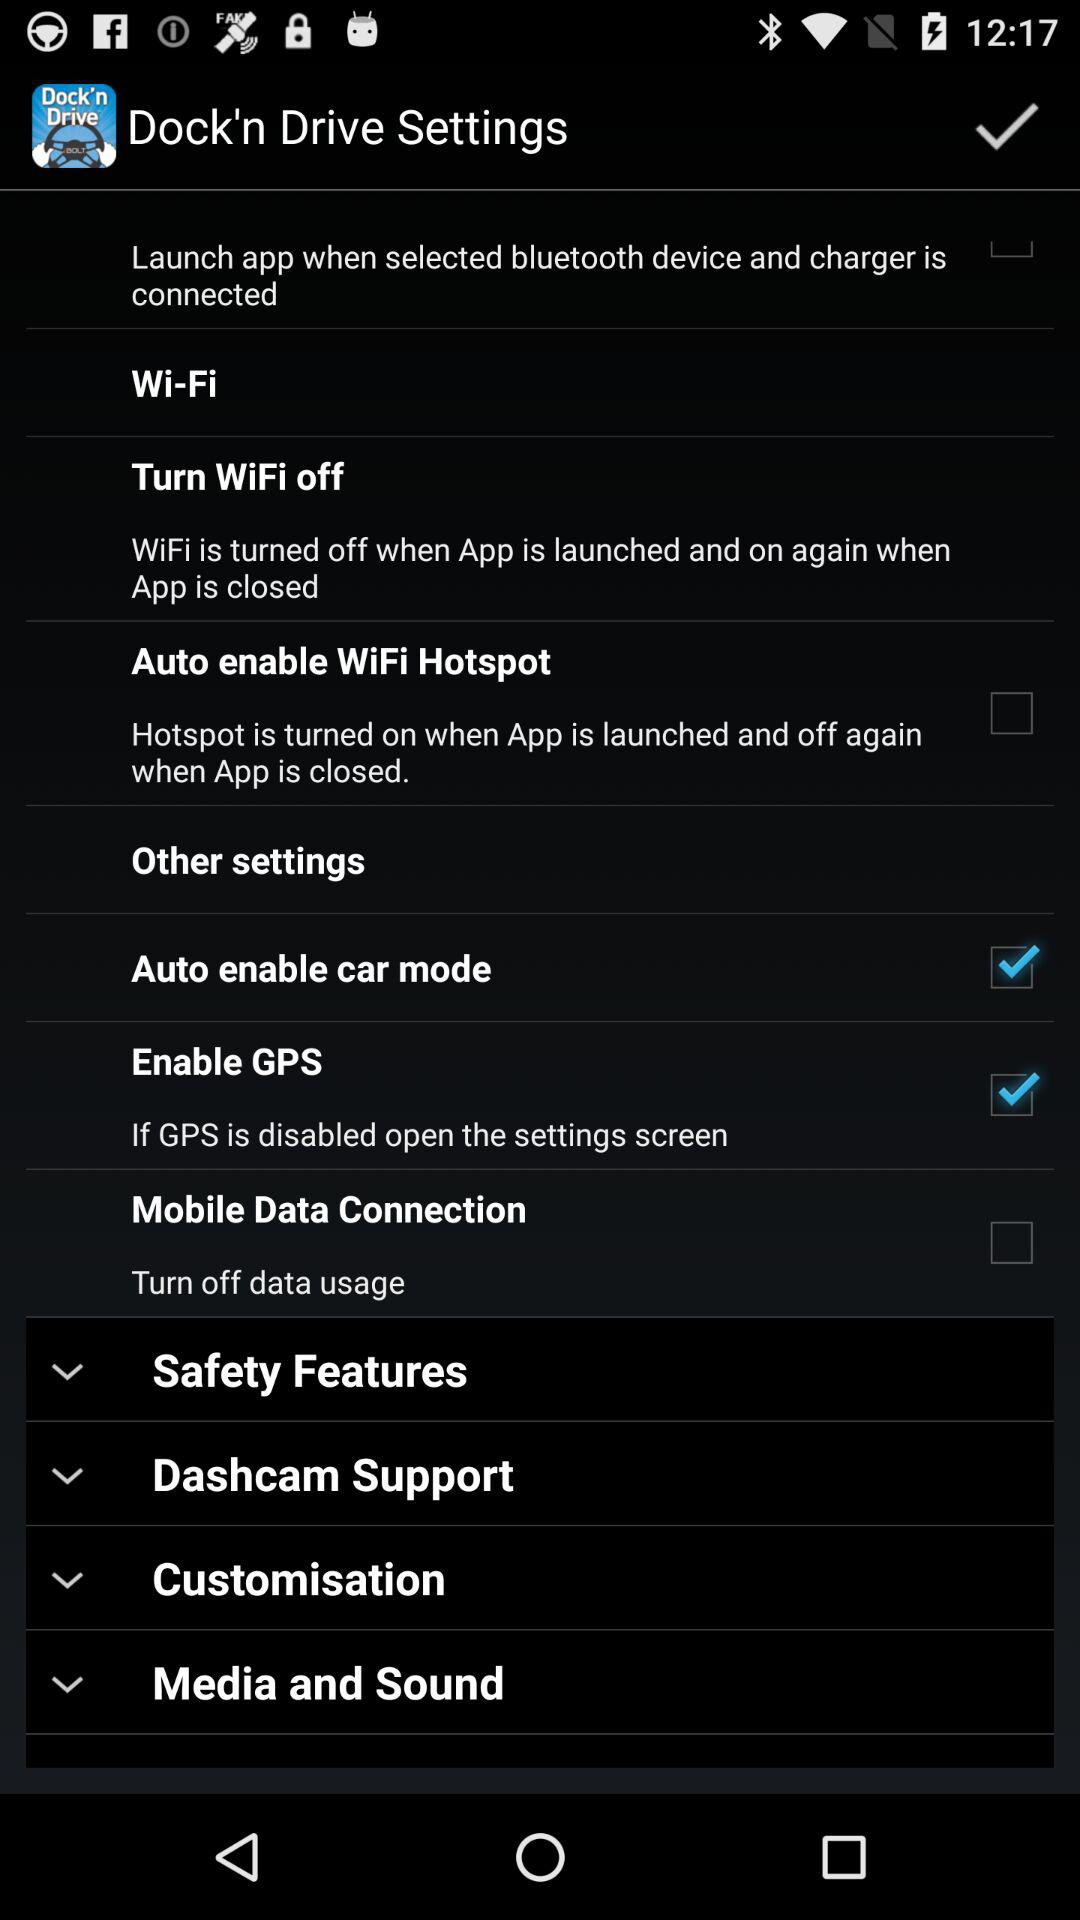What is the status of "Enable GPS"? The status is "on". 